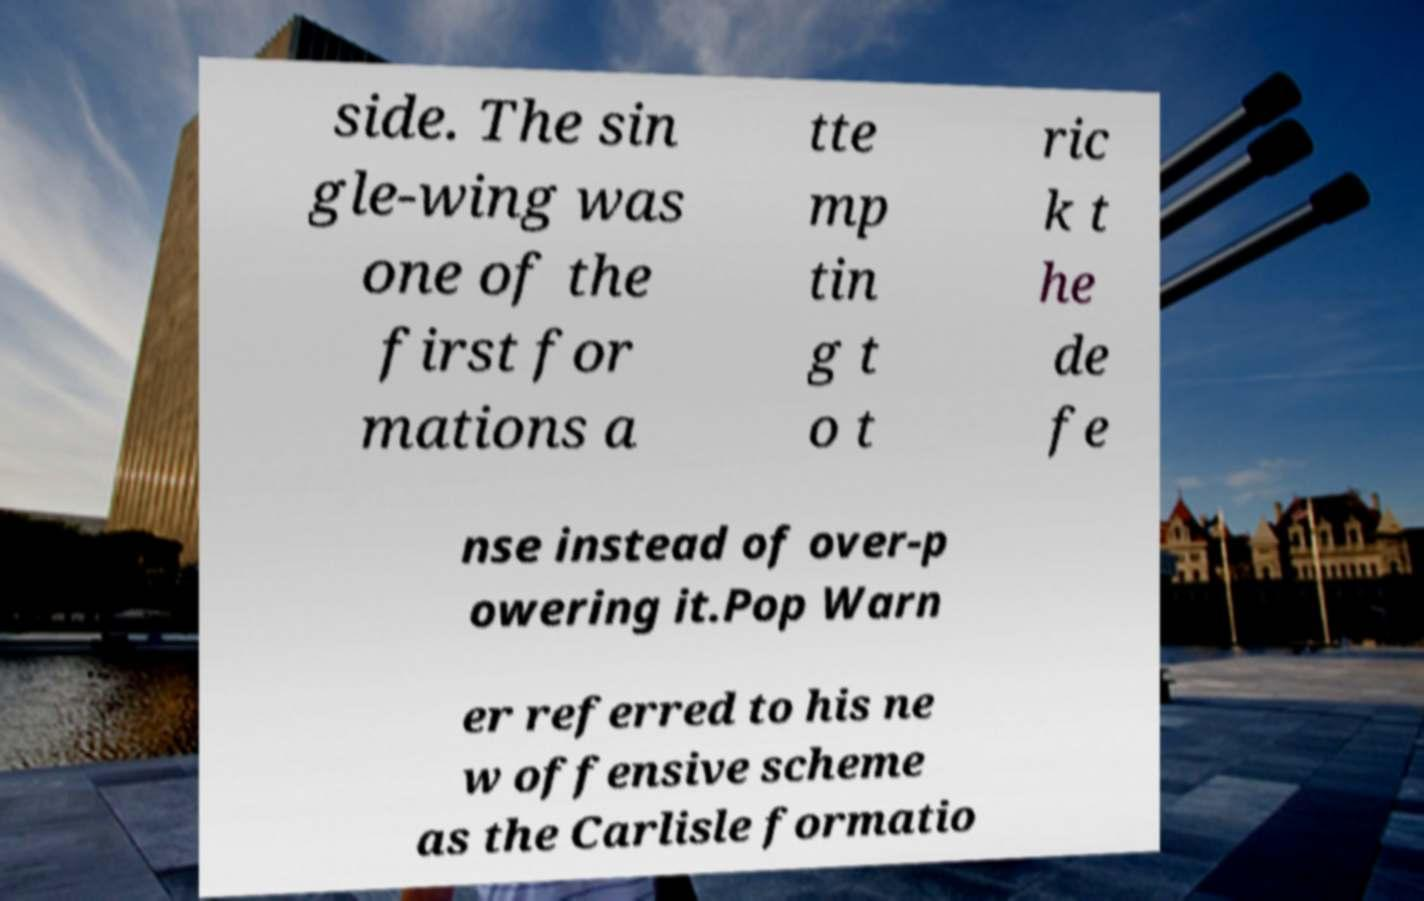What messages or text are displayed in this image? I need them in a readable, typed format. side. The sin gle-wing was one of the first for mations a tte mp tin g t o t ric k t he de fe nse instead of over-p owering it.Pop Warn er referred to his ne w offensive scheme as the Carlisle formatio 